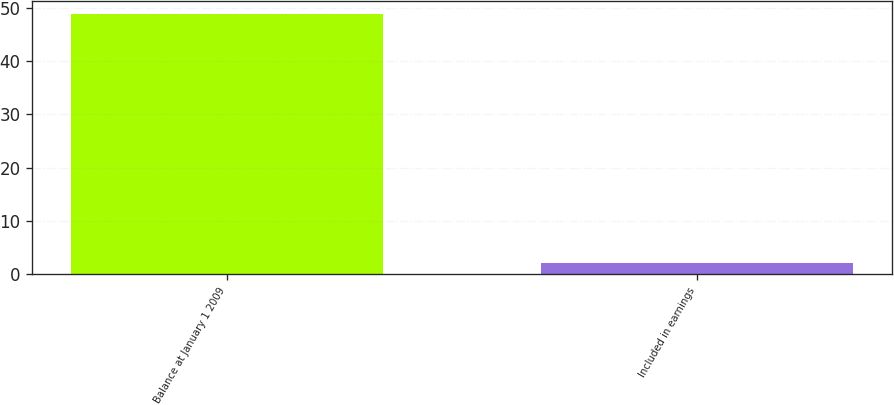Convert chart to OTSL. <chart><loc_0><loc_0><loc_500><loc_500><bar_chart><fcel>Balance at January 1 2009<fcel>Included in earnings<nl><fcel>49<fcel>2<nl></chart> 